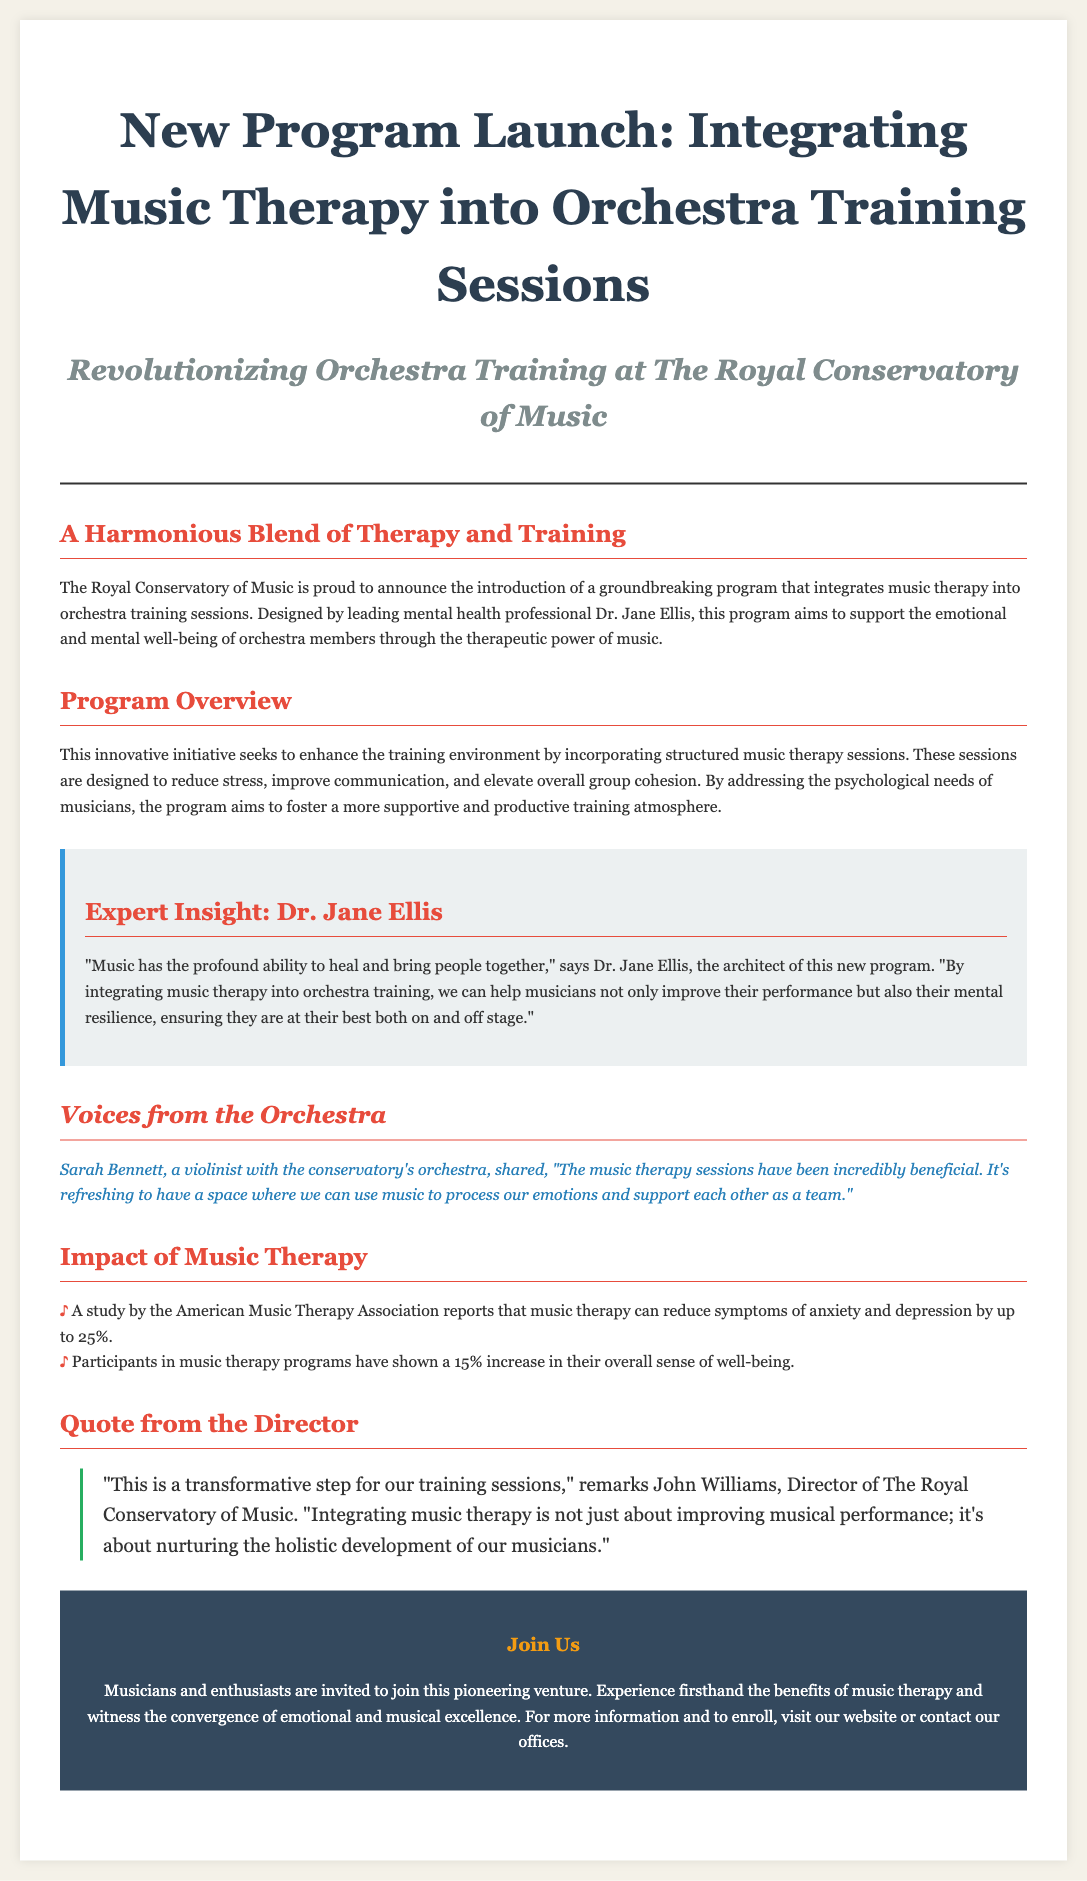What is the title of the new program? The title of the new program is "Integrating Music Therapy into Orchestra Training Sessions."
Answer: Integrating Music Therapy into Orchestra Training Sessions Who is the leading mental health professional behind the program? The leading mental health professional behind the program is Dr. Jane Ellis.
Answer: Dr. Jane Ellis What percentage can music therapy reduce symptoms of anxiety and depression? A study reports that music therapy can reduce symptoms of anxiety and depression by up to 25%.
Answer: 25% What is the main goal of integrating music therapy into orchestra training? The main goal of integrating music therapy is to support the emotional and mental well-being of orchestra members.
Answer: Support emotional and mental well-being Which orchestra member shared a testimonial about the music therapy sessions? Sarah Bennett, a violinist, shared a testimonial about the music therapy sessions.
Answer: Sarah Bennett What transformative step does the Director of The Royal Conservatory of Music mention? The Director mentions that integrating music therapy is a transformative step for training sessions.
Answer: Transformative step for training sessions What type of document layout is this? This document is laid out as a newspaper layout.
Answer: Newspaper layout 